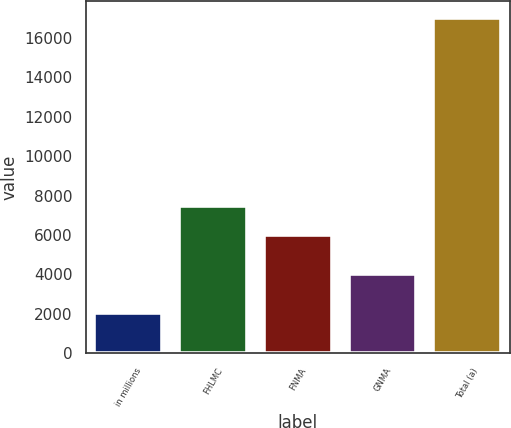Convert chart. <chart><loc_0><loc_0><loc_500><loc_500><bar_chart><fcel>in millions<fcel>FHLMC<fcel>FNMA<fcel>GNMA<fcel>Total (a)<nl><fcel>2013<fcel>7478.9<fcel>5978<fcel>3997<fcel>17022<nl></chart> 